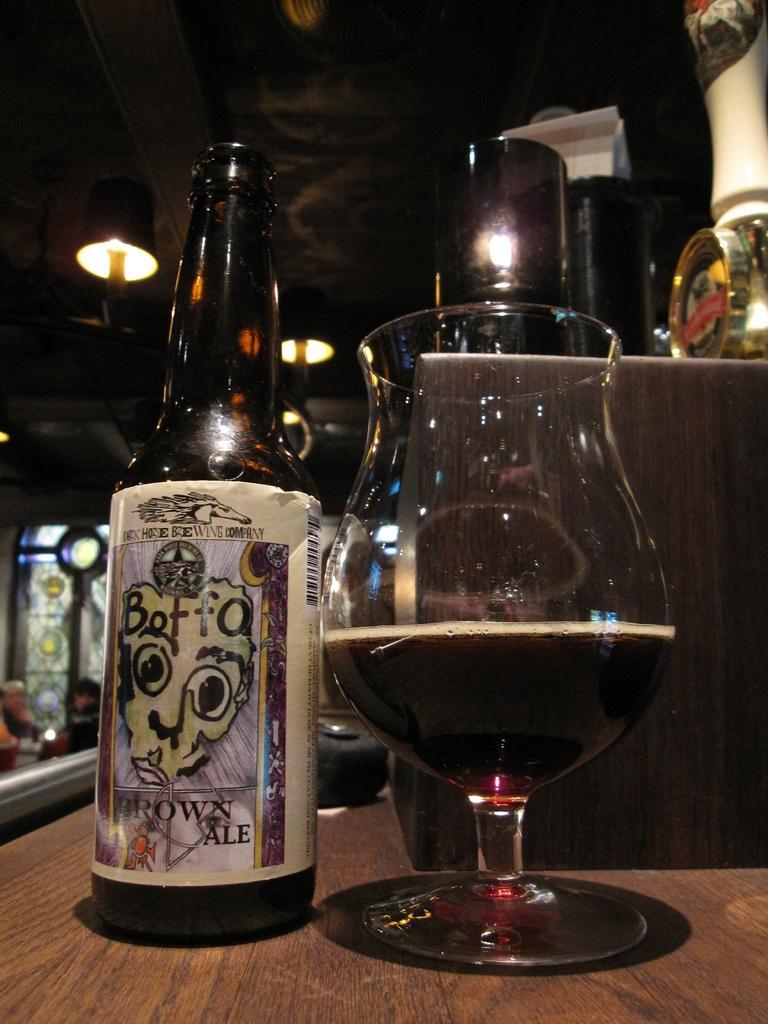Can you describe this image briefly? In this image, we can see a glass with drink and there is a bottle and some other objects on the table. In the background, there are lights and we can see some people. 